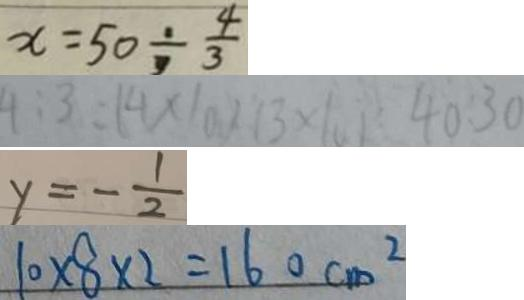<formula> <loc_0><loc_0><loc_500><loc_500>x = 5 0 \div \frac { 4 } { 3 } 
 4 : 3 = ( 4 \times 1 0 ) : ( 3 \times 1 0 ) = 4 0 : 3 0 
 y = - \frac { 1 } { 2 } 
 1 0 \times 8 \times 2 = 1 6 0 c m ^ { 2 }</formula> 